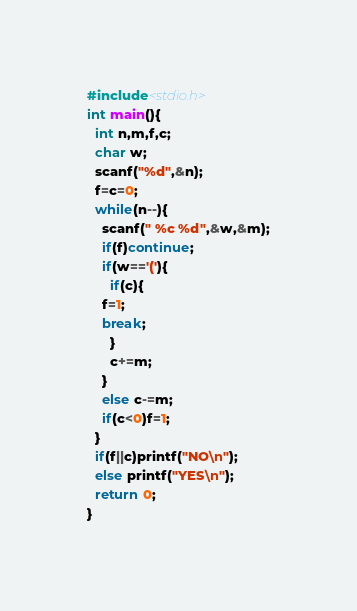Convert code to text. <code><loc_0><loc_0><loc_500><loc_500><_C_>#include<stdio.h>
int main(){
  int n,m,f,c;
  char w;
  scanf("%d",&n);
  f=c=0;
  while(n--){
    scanf(" %c %d",&w,&m);
    if(f)continue;
    if(w=='('){
      if(c){
	f=1;
	break;
      }
      c+=m;
    }
    else c-=m;
    if(c<0)f=1;
  }
  if(f||c)printf("NO\n");
  else printf("YES\n"); 
  return 0;
}</code> 